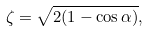<formula> <loc_0><loc_0><loc_500><loc_500>\zeta = \sqrt { 2 ( 1 - \cos \alpha ) } ,</formula> 